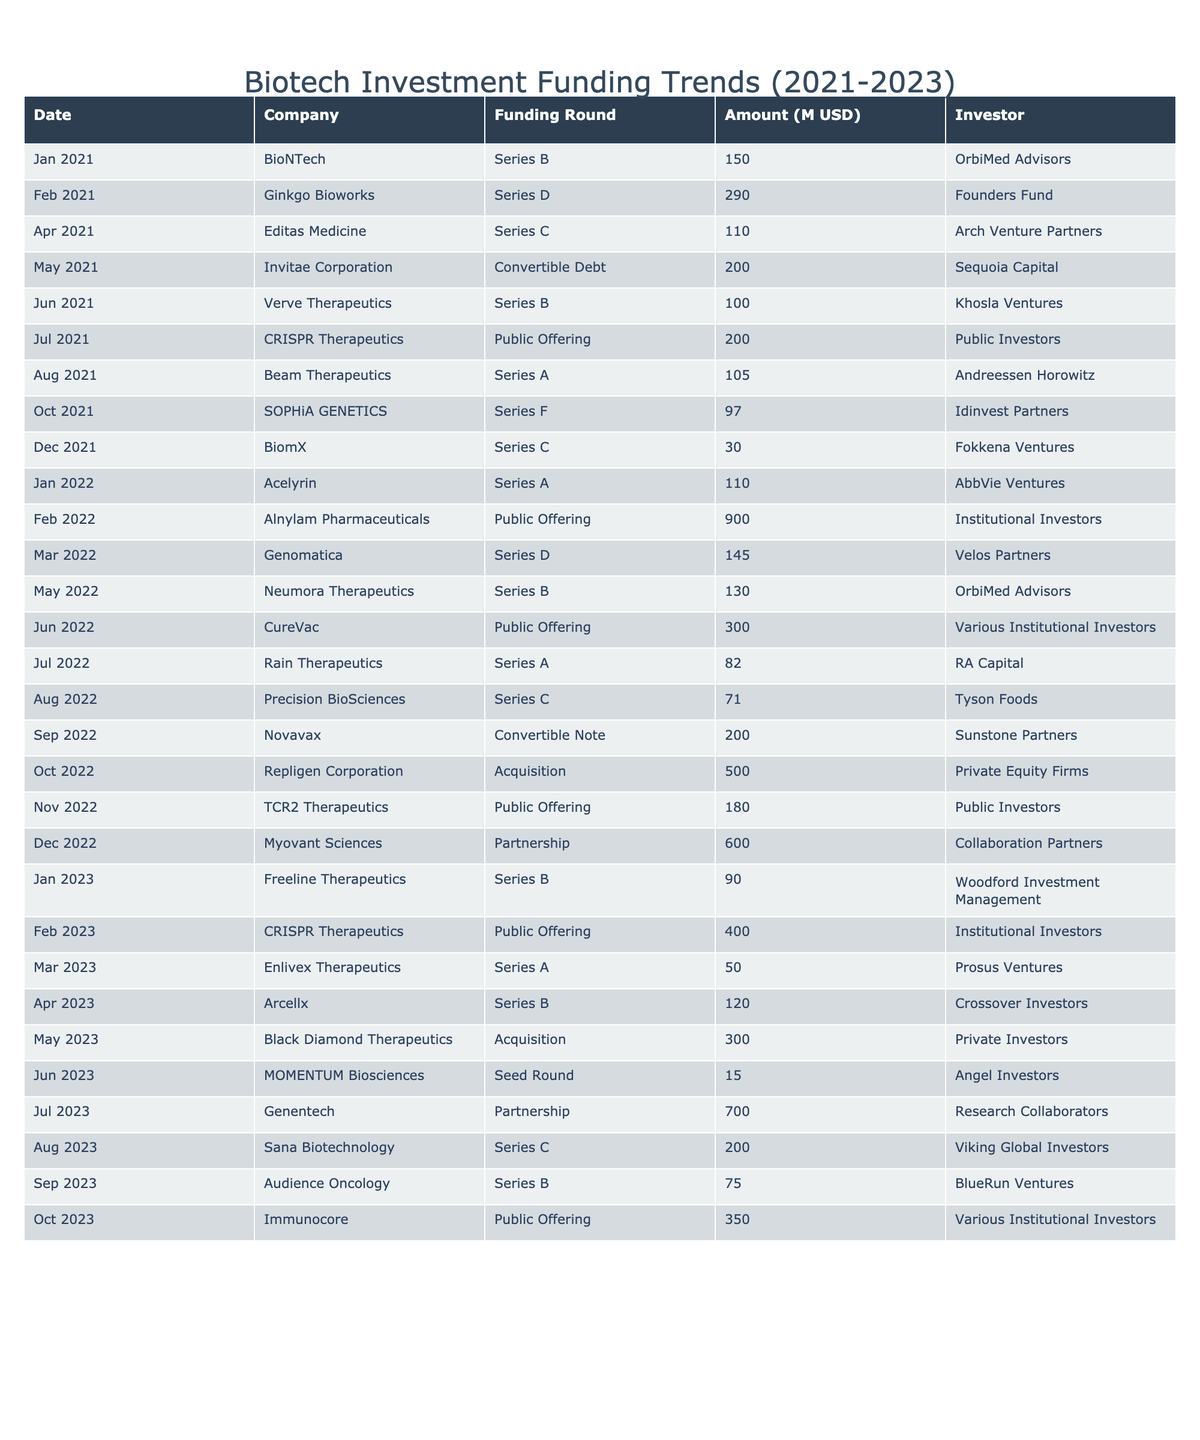What was the highest funding amount recorded in 2022? In the table, by scanning through the 'Amount (in millions USD)' column for 2022, the maximum value found is 900 million USD for Alnylam Pharmaceuticals in February 2022.
Answer: 900 million USD Which company had the lowest funding amount in 2021? Looking at the 'Amount (in millions USD)' for 2021, the smallest amount is 30 million USD, which was raised by BiomX in December 2021.
Answer: 30 million USD How many companies received funding in April across the three years? By counting the entries for the month of April across the years 2021, 2022, and 2023, we find 3 companies: Editas Medicine (2021), Arcellx (2023), and CureVac (2022). Therefore, the total is 3 companies.
Answer: 3 companies Did Ginkgo Bioworks receive a higher funding amount than BioNTech in 2021? Ginkgo Bioworks received 290 million USD in February 2021 while BioNTech received 150 million USD in January 2021. Since 290 million is greater than 150 million, the answer is yes.
Answer: Yes What is the total amount funded in 2023? To find the total for 2023, we add the amounts: 90 + 400 + 50 + 120 + 300 + 15 + 700 + 200 + 75 + 350, which sums to 2000 million USD.
Answer: 2000 million USD Which investor participated in both a public offering and an acquisition in 2022? By examining the 'Investor' column, we see that Public Investors were involved in two different funding events: the public offering for Alnylam Pharmaceuticals in February 2022 and the public offering for TCR2 Therapeutics in November 2022, and they were not involved in any acquisitions. This makes the answer no.
Answer: No What percentage of total funding in 2021 came from the top three funding rounds? The total funding in 2021 is 1,900 million USD (150 + 290 + 110 + 200 + 100 + 200 + 105 + 97 + 30) = 1,882 million, and the top three rounds are 290 million (Ginkgo Bioworks) + 200 million (CRISPR Therapeutics) + 200 million (Invitae Corporation) = 690 million USD. The percentage is calculated as (690 / 1882) * 100, which is approximately 36.7%.
Answer: Approximately 36.7% How many total public offerings were recorded in 2022? Counting the instances of public offerings in 2022 yields: February (Alnylam Pharmaceuticals), June (CureVac), November (TCR2 Therapeutics), resulting in a total of 3 public offerings for the year.
Answer: 3 public offerings Which month had the highest funding total across all companies in 2021? By examining the monthly funding totals, July stands out with CRISPR Therapeutics amounting to 200 million USD, the highest single month amount of 2021.
Answer: July 2021 